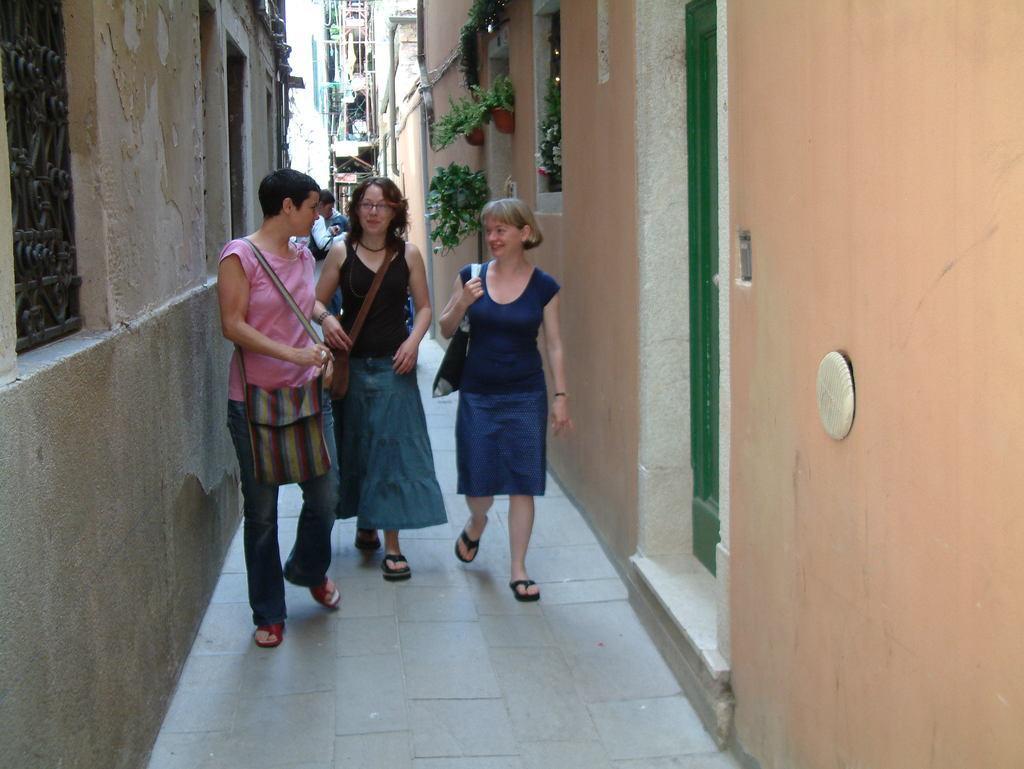In one or two sentences, can you explain what this image depicts? In this image we can see people and there are buildings. On the right there are house plants. On the left there is a window and we can see a door. 